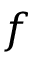Convert formula to latex. <formula><loc_0><loc_0><loc_500><loc_500>f</formula> 